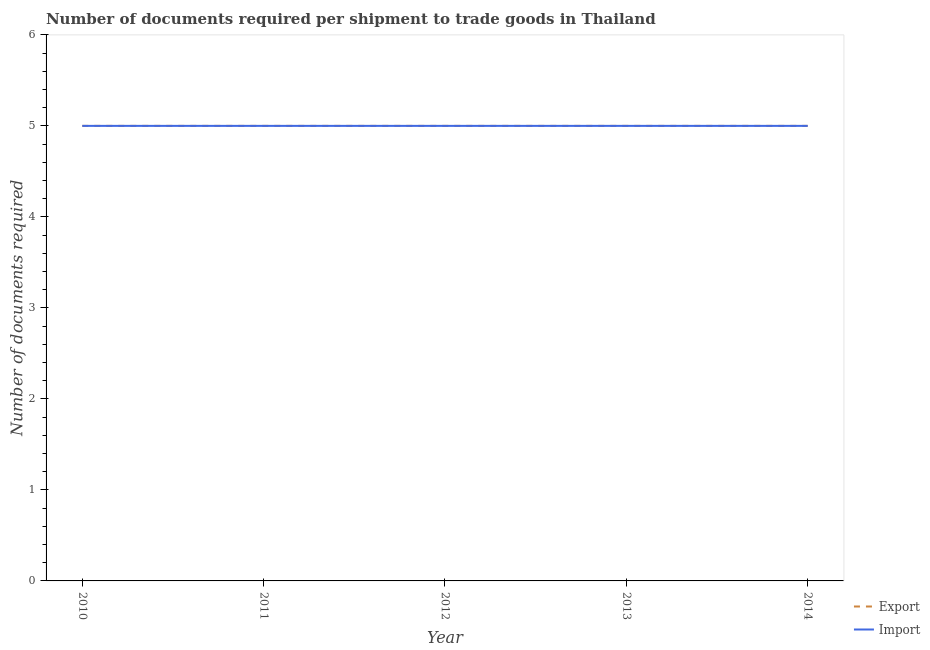How many different coloured lines are there?
Offer a very short reply. 2. What is the number of documents required to export goods in 2012?
Your answer should be compact. 5. Across all years, what is the maximum number of documents required to import goods?
Give a very brief answer. 5. Across all years, what is the minimum number of documents required to export goods?
Make the answer very short. 5. In which year was the number of documents required to export goods minimum?
Ensure brevity in your answer.  2010. What is the total number of documents required to export goods in the graph?
Make the answer very short. 25. What is the difference between the number of documents required to export goods in 2012 and that in 2014?
Your response must be concise. 0. In the year 2012, what is the difference between the number of documents required to import goods and number of documents required to export goods?
Keep it short and to the point. 0. In how many years, is the number of documents required to export goods greater than 5.8?
Offer a very short reply. 0. What is the ratio of the number of documents required to export goods in 2010 to that in 2012?
Your answer should be compact. 1. Is the number of documents required to import goods in 2011 less than that in 2013?
Offer a very short reply. No. Is the difference between the number of documents required to export goods in 2010 and 2013 greater than the difference between the number of documents required to import goods in 2010 and 2013?
Make the answer very short. No. What is the difference between the highest and the second highest number of documents required to import goods?
Offer a terse response. 0. What is the difference between the highest and the lowest number of documents required to import goods?
Your answer should be compact. 0. Does the number of documents required to import goods monotonically increase over the years?
Offer a very short reply. No. Is the number of documents required to import goods strictly greater than the number of documents required to export goods over the years?
Provide a succinct answer. No. Is the number of documents required to import goods strictly less than the number of documents required to export goods over the years?
Your answer should be very brief. No. How many years are there in the graph?
Provide a succinct answer. 5. What is the difference between two consecutive major ticks on the Y-axis?
Your answer should be compact. 1. Are the values on the major ticks of Y-axis written in scientific E-notation?
Keep it short and to the point. No. Does the graph contain any zero values?
Your answer should be very brief. No. Does the graph contain grids?
Provide a short and direct response. No. How many legend labels are there?
Offer a terse response. 2. How are the legend labels stacked?
Offer a very short reply. Vertical. What is the title of the graph?
Your response must be concise. Number of documents required per shipment to trade goods in Thailand. Does "Savings" appear as one of the legend labels in the graph?
Make the answer very short. No. What is the label or title of the X-axis?
Your answer should be very brief. Year. What is the label or title of the Y-axis?
Your answer should be very brief. Number of documents required. What is the Number of documents required in Export in 2010?
Provide a succinct answer. 5. What is the Number of documents required in Export in 2011?
Make the answer very short. 5. What is the Number of documents required of Export in 2012?
Make the answer very short. 5. What is the Number of documents required in Import in 2012?
Offer a very short reply. 5. What is the Number of documents required of Import in 2013?
Your response must be concise. 5. What is the Number of documents required of Import in 2014?
Provide a succinct answer. 5. Across all years, what is the maximum Number of documents required in Export?
Give a very brief answer. 5. Across all years, what is the minimum Number of documents required in Export?
Your answer should be compact. 5. Across all years, what is the minimum Number of documents required in Import?
Keep it short and to the point. 5. What is the total Number of documents required of Import in the graph?
Your answer should be compact. 25. What is the difference between the Number of documents required in Import in 2010 and that in 2011?
Your response must be concise. 0. What is the difference between the Number of documents required of Export in 2010 and that in 2012?
Your answer should be compact. 0. What is the difference between the Number of documents required in Import in 2010 and that in 2012?
Make the answer very short. 0. What is the difference between the Number of documents required of Import in 2010 and that in 2013?
Your answer should be very brief. 0. What is the difference between the Number of documents required in Export in 2010 and that in 2014?
Make the answer very short. 0. What is the difference between the Number of documents required in Import in 2011 and that in 2013?
Provide a short and direct response. 0. What is the difference between the Number of documents required of Export in 2011 and that in 2014?
Ensure brevity in your answer.  0. What is the difference between the Number of documents required of Import in 2012 and that in 2013?
Provide a succinct answer. 0. What is the difference between the Number of documents required in Export in 2013 and that in 2014?
Ensure brevity in your answer.  0. What is the difference between the Number of documents required in Export in 2010 and the Number of documents required in Import in 2011?
Provide a succinct answer. 0. What is the difference between the Number of documents required of Export in 2010 and the Number of documents required of Import in 2013?
Offer a very short reply. 0. What is the difference between the Number of documents required of Export in 2011 and the Number of documents required of Import in 2012?
Provide a short and direct response. 0. What is the difference between the Number of documents required in Export in 2011 and the Number of documents required in Import in 2014?
Your response must be concise. 0. What is the difference between the Number of documents required of Export in 2012 and the Number of documents required of Import in 2013?
Give a very brief answer. 0. What is the difference between the Number of documents required in Export in 2012 and the Number of documents required in Import in 2014?
Your answer should be compact. 0. What is the average Number of documents required of Import per year?
Make the answer very short. 5. In the year 2010, what is the difference between the Number of documents required of Export and Number of documents required of Import?
Provide a short and direct response. 0. In the year 2012, what is the difference between the Number of documents required of Export and Number of documents required of Import?
Ensure brevity in your answer.  0. What is the ratio of the Number of documents required in Export in 2010 to that in 2011?
Your response must be concise. 1. What is the ratio of the Number of documents required in Export in 2010 to that in 2012?
Offer a terse response. 1. What is the ratio of the Number of documents required in Import in 2010 to that in 2012?
Offer a terse response. 1. What is the ratio of the Number of documents required in Export in 2010 to that in 2013?
Make the answer very short. 1. What is the ratio of the Number of documents required in Export in 2010 to that in 2014?
Offer a terse response. 1. What is the ratio of the Number of documents required in Export in 2011 to that in 2012?
Offer a very short reply. 1. What is the ratio of the Number of documents required of Export in 2011 to that in 2013?
Ensure brevity in your answer.  1. What is the ratio of the Number of documents required of Import in 2011 to that in 2014?
Your response must be concise. 1. What is the ratio of the Number of documents required of Import in 2012 to that in 2013?
Provide a short and direct response. 1. What is the ratio of the Number of documents required of Import in 2012 to that in 2014?
Make the answer very short. 1. What is the difference between the highest and the second highest Number of documents required of Import?
Keep it short and to the point. 0. What is the difference between the highest and the lowest Number of documents required in Export?
Your response must be concise. 0. 